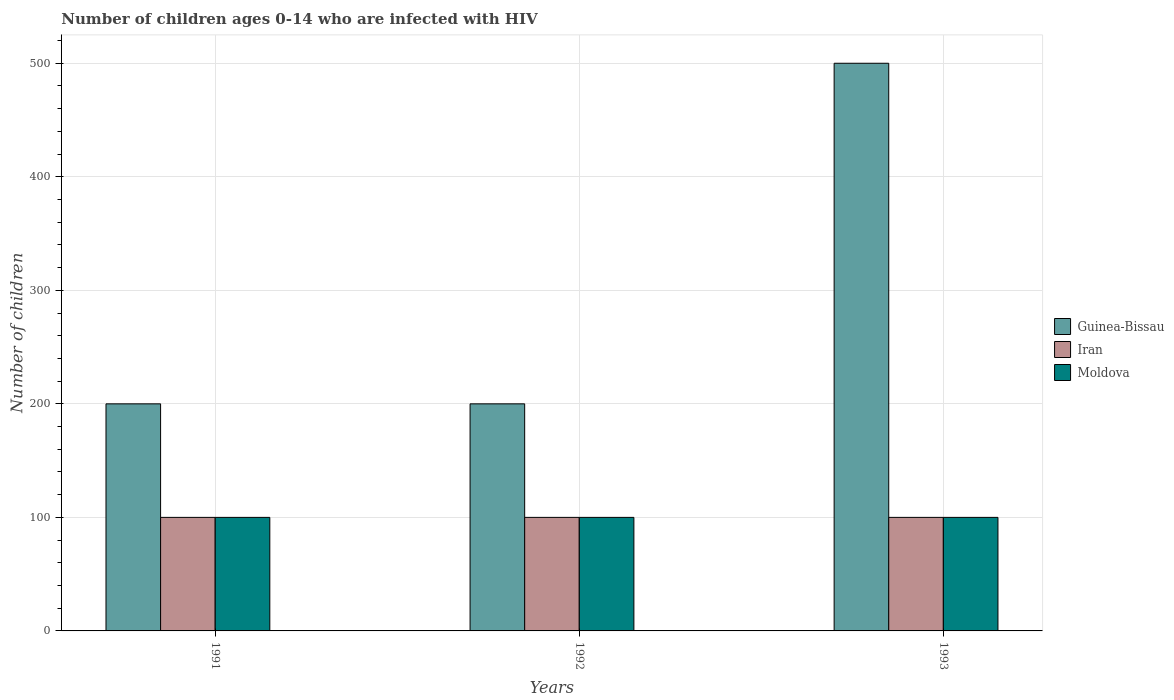Are the number of bars per tick equal to the number of legend labels?
Your response must be concise. Yes. Are the number of bars on each tick of the X-axis equal?
Your answer should be very brief. Yes. How many bars are there on the 3rd tick from the left?
Make the answer very short. 3. What is the number of HIV infected children in Iran in 1991?
Give a very brief answer. 100. Across all years, what is the maximum number of HIV infected children in Iran?
Your answer should be very brief. 100. Across all years, what is the minimum number of HIV infected children in Moldova?
Keep it short and to the point. 100. In which year was the number of HIV infected children in Moldova maximum?
Offer a very short reply. 1991. What is the total number of HIV infected children in Guinea-Bissau in the graph?
Make the answer very short. 900. What is the difference between the number of HIV infected children in Moldova in 1991 and that in 1992?
Provide a succinct answer. 0. What is the difference between the number of HIV infected children in Guinea-Bissau in 1992 and the number of HIV infected children in Iran in 1993?
Make the answer very short. 100. What is the average number of HIV infected children in Guinea-Bissau per year?
Provide a short and direct response. 300. In the year 1993, what is the difference between the number of HIV infected children in Iran and number of HIV infected children in Guinea-Bissau?
Keep it short and to the point. -400. Is the number of HIV infected children in Moldova in 1991 less than that in 1992?
Keep it short and to the point. No. Is the difference between the number of HIV infected children in Iran in 1991 and 1993 greater than the difference between the number of HIV infected children in Guinea-Bissau in 1991 and 1993?
Your response must be concise. Yes. What is the difference between the highest and the second highest number of HIV infected children in Guinea-Bissau?
Provide a succinct answer. 300. What is the difference between the highest and the lowest number of HIV infected children in Guinea-Bissau?
Make the answer very short. 300. In how many years, is the number of HIV infected children in Guinea-Bissau greater than the average number of HIV infected children in Guinea-Bissau taken over all years?
Your answer should be compact. 1. Is the sum of the number of HIV infected children in Moldova in 1991 and 1992 greater than the maximum number of HIV infected children in Iran across all years?
Offer a very short reply. Yes. What does the 1st bar from the left in 1991 represents?
Your answer should be very brief. Guinea-Bissau. What does the 1st bar from the right in 1992 represents?
Keep it short and to the point. Moldova. Is it the case that in every year, the sum of the number of HIV infected children in Moldova and number of HIV infected children in Guinea-Bissau is greater than the number of HIV infected children in Iran?
Keep it short and to the point. Yes. How many years are there in the graph?
Give a very brief answer. 3. Are the values on the major ticks of Y-axis written in scientific E-notation?
Keep it short and to the point. No. Does the graph contain any zero values?
Your answer should be compact. No. Does the graph contain grids?
Your answer should be very brief. Yes. How are the legend labels stacked?
Provide a short and direct response. Vertical. What is the title of the graph?
Keep it short and to the point. Number of children ages 0-14 who are infected with HIV. What is the label or title of the X-axis?
Give a very brief answer. Years. What is the label or title of the Y-axis?
Your answer should be very brief. Number of children. What is the Number of children of Moldova in 1991?
Your answer should be compact. 100. What is the Number of children in Iran in 1992?
Provide a short and direct response. 100. What is the Number of children in Moldova in 1992?
Provide a short and direct response. 100. What is the Number of children of Guinea-Bissau in 1993?
Provide a succinct answer. 500. What is the Number of children in Moldova in 1993?
Your answer should be very brief. 100. Across all years, what is the maximum Number of children of Moldova?
Your response must be concise. 100. Across all years, what is the minimum Number of children in Guinea-Bissau?
Your answer should be very brief. 200. Across all years, what is the minimum Number of children in Moldova?
Keep it short and to the point. 100. What is the total Number of children of Guinea-Bissau in the graph?
Offer a very short reply. 900. What is the total Number of children of Iran in the graph?
Keep it short and to the point. 300. What is the total Number of children of Moldova in the graph?
Provide a short and direct response. 300. What is the difference between the Number of children of Guinea-Bissau in 1991 and that in 1993?
Make the answer very short. -300. What is the difference between the Number of children in Moldova in 1991 and that in 1993?
Make the answer very short. 0. What is the difference between the Number of children in Guinea-Bissau in 1992 and that in 1993?
Keep it short and to the point. -300. What is the difference between the Number of children in Iran in 1992 and that in 1993?
Give a very brief answer. 0. What is the difference between the Number of children of Guinea-Bissau in 1991 and the Number of children of Moldova in 1992?
Make the answer very short. 100. What is the difference between the Number of children of Guinea-Bissau in 1991 and the Number of children of Iran in 1993?
Your answer should be very brief. 100. What is the difference between the Number of children of Guinea-Bissau in 1992 and the Number of children of Moldova in 1993?
Give a very brief answer. 100. What is the average Number of children in Guinea-Bissau per year?
Give a very brief answer. 300. What is the average Number of children in Moldova per year?
Keep it short and to the point. 100. In the year 1991, what is the difference between the Number of children of Iran and Number of children of Moldova?
Your response must be concise. 0. In the year 1993, what is the difference between the Number of children of Guinea-Bissau and Number of children of Iran?
Your response must be concise. 400. In the year 1993, what is the difference between the Number of children in Iran and Number of children in Moldova?
Keep it short and to the point. 0. What is the ratio of the Number of children of Guinea-Bissau in 1991 to that in 1992?
Offer a very short reply. 1. What is the ratio of the Number of children in Moldova in 1991 to that in 1992?
Provide a short and direct response. 1. What is the ratio of the Number of children of Guinea-Bissau in 1991 to that in 1993?
Your answer should be very brief. 0.4. What is the ratio of the Number of children of Moldova in 1991 to that in 1993?
Ensure brevity in your answer.  1. What is the ratio of the Number of children in Guinea-Bissau in 1992 to that in 1993?
Give a very brief answer. 0.4. What is the difference between the highest and the second highest Number of children in Guinea-Bissau?
Your answer should be compact. 300. What is the difference between the highest and the lowest Number of children in Guinea-Bissau?
Give a very brief answer. 300. What is the difference between the highest and the lowest Number of children in Iran?
Keep it short and to the point. 0. 